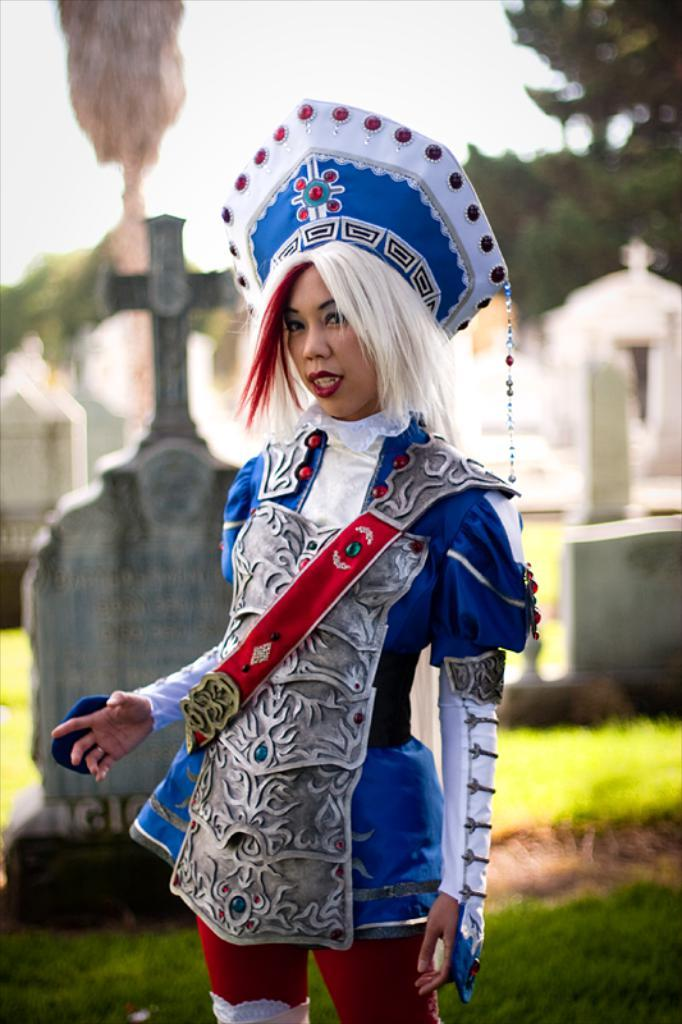Who is present in the image? There is a woman in the image. What is the woman wearing? The woman is wearing a blue dress. Where is the woman standing? The woman is standing on the grass. What can be seen in the background of the image? There are graves, trees, and the sky visible in the background of the image. What type of cake is being served at the car show in the image? There is no cake or car show present in the image; it features a woman standing on the grass with graves, trees, and the sky visible in the background. 